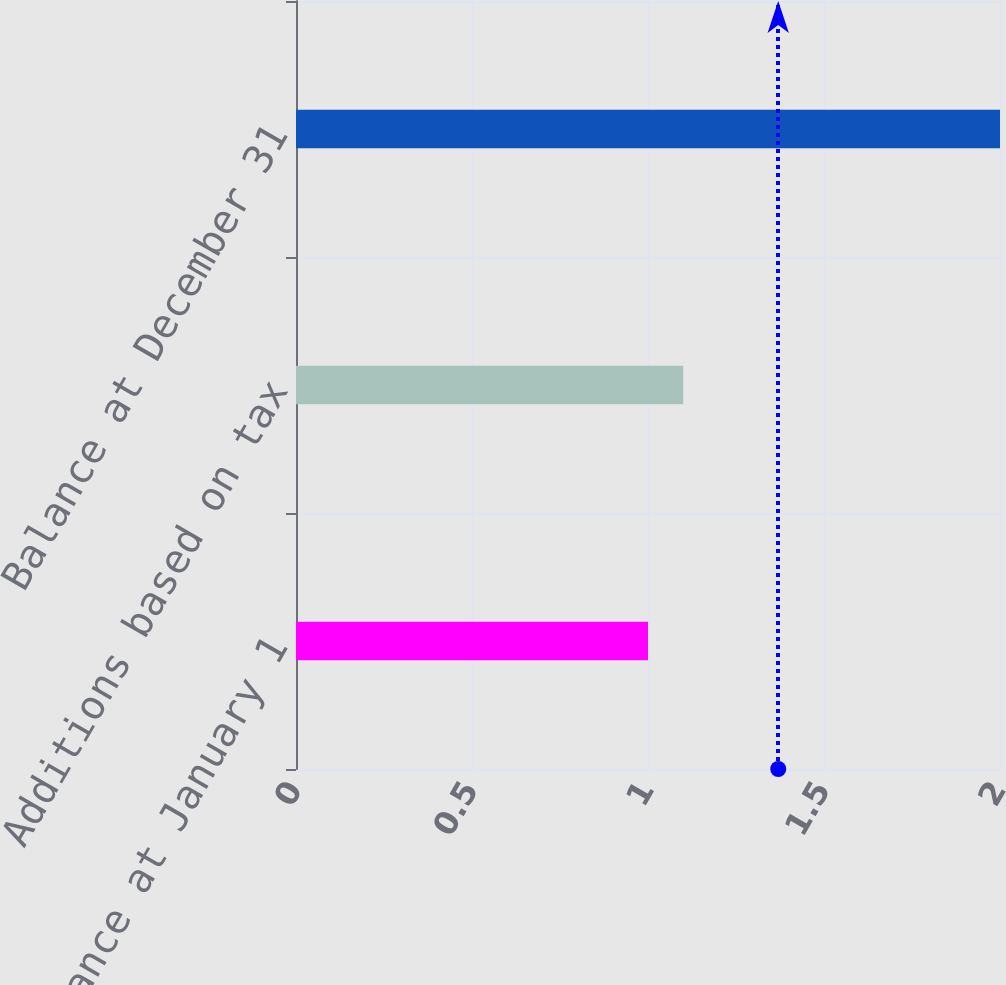Convert chart to OTSL. <chart><loc_0><loc_0><loc_500><loc_500><bar_chart><fcel>Balance at January 1<fcel>Additions based on tax<fcel>Balance at December 31<nl><fcel>1<fcel>1.1<fcel>2<nl></chart> 